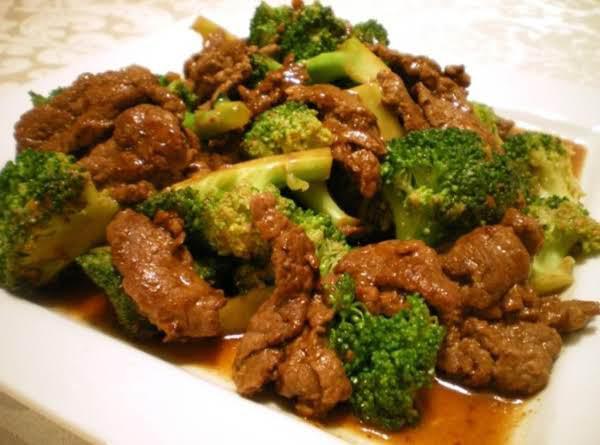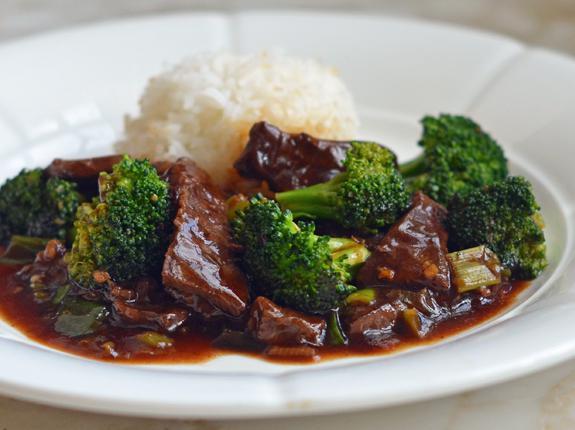The first image is the image on the left, the second image is the image on the right. Assess this claim about the two images: "Two beef and broccoli meals are served on white plates, one with rice and one with no rice.". Correct or not? Answer yes or no. Yes. The first image is the image on the left, the second image is the image on the right. Examine the images to the left and right. Is the description "The food in the image on the right is being served in a white dish." accurate? Answer yes or no. Yes. The first image is the image on the left, the second image is the image on the right. Analyze the images presented: Is the assertion "Right image shows a white plate containing an entree that includes white rice and broccoli." valid? Answer yes or no. Yes. 